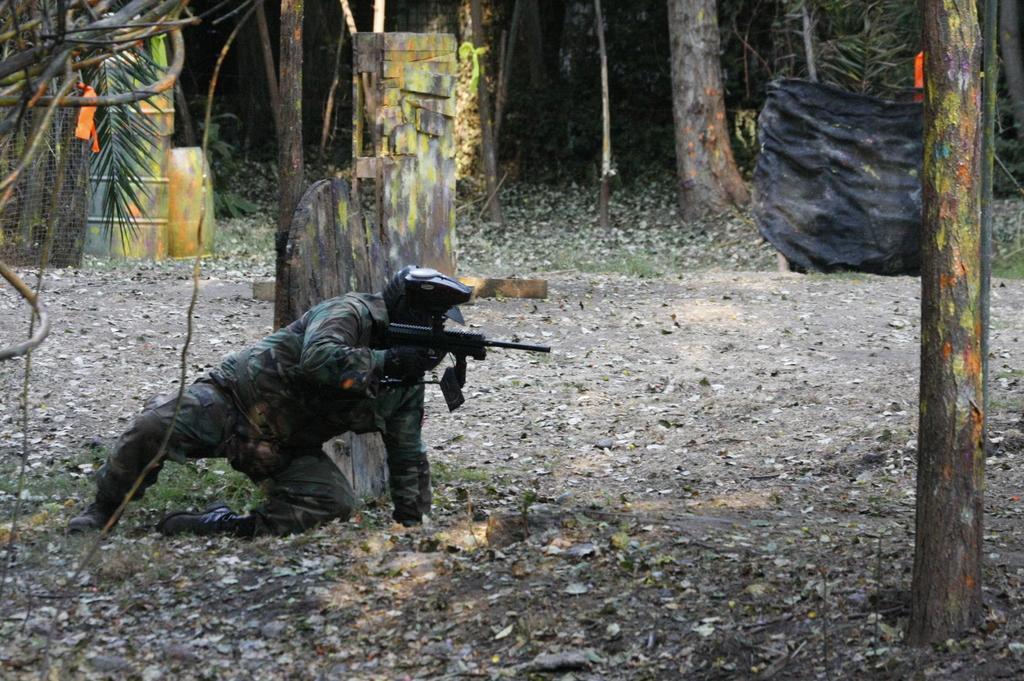In one or two sentences, can you explain what this image depicts? In the background we can see tree trunks, leaves. In this picture we can see objects, grass and messy ground. On the left side of the picture we can see a man in a crouched position, wearing a helmet and he is holding a gun. 